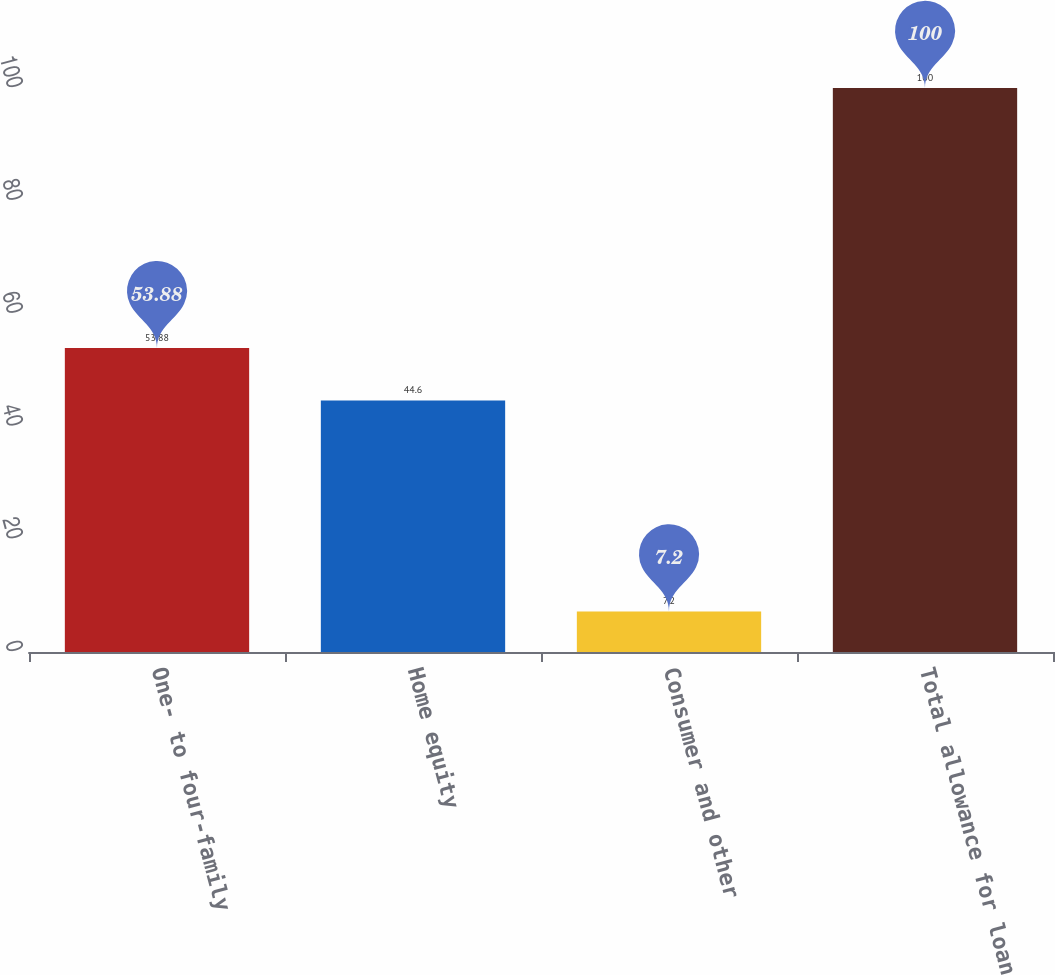Convert chart. <chart><loc_0><loc_0><loc_500><loc_500><bar_chart><fcel>One- to four-family<fcel>Home equity<fcel>Consumer and other<fcel>Total allowance for loan<nl><fcel>53.88<fcel>44.6<fcel>7.2<fcel>100<nl></chart> 